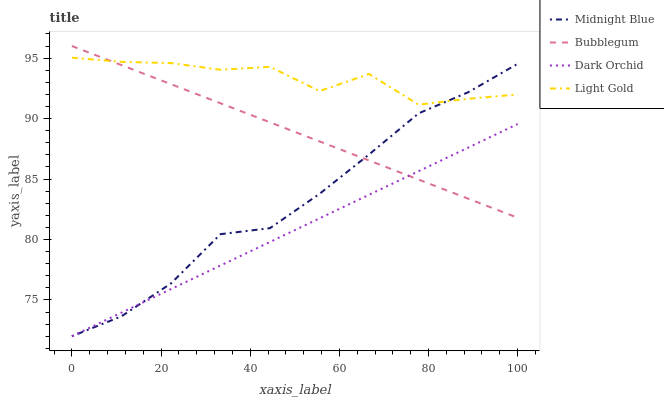Does Midnight Blue have the minimum area under the curve?
Answer yes or no. No. Does Midnight Blue have the maximum area under the curve?
Answer yes or no. No. Is Midnight Blue the smoothest?
Answer yes or no. No. Is Midnight Blue the roughest?
Answer yes or no. No. Does Light Gold have the lowest value?
Answer yes or no. No. Does Light Gold have the highest value?
Answer yes or no. No. Is Dark Orchid less than Light Gold?
Answer yes or no. Yes. Is Light Gold greater than Dark Orchid?
Answer yes or no. Yes. Does Dark Orchid intersect Light Gold?
Answer yes or no. No. 